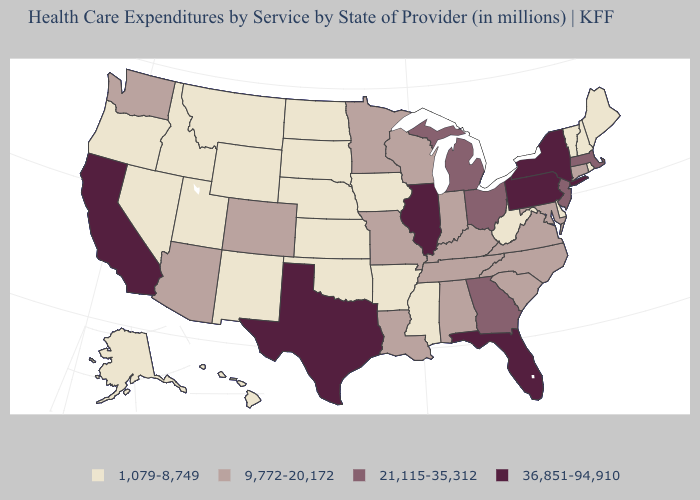What is the value of Vermont?
Answer briefly. 1,079-8,749. What is the highest value in the Northeast ?
Concise answer only. 36,851-94,910. What is the value of Ohio?
Keep it brief. 21,115-35,312. Among the states that border New Hampshire , which have the lowest value?
Write a very short answer. Maine, Vermont. Name the states that have a value in the range 1,079-8,749?
Answer briefly. Alaska, Arkansas, Delaware, Hawaii, Idaho, Iowa, Kansas, Maine, Mississippi, Montana, Nebraska, Nevada, New Hampshire, New Mexico, North Dakota, Oklahoma, Oregon, Rhode Island, South Dakota, Utah, Vermont, West Virginia, Wyoming. Name the states that have a value in the range 21,115-35,312?
Give a very brief answer. Georgia, Massachusetts, Michigan, New Jersey, Ohio. Does the map have missing data?
Answer briefly. No. Name the states that have a value in the range 9,772-20,172?
Answer briefly. Alabama, Arizona, Colorado, Connecticut, Indiana, Kentucky, Louisiana, Maryland, Minnesota, Missouri, North Carolina, South Carolina, Tennessee, Virginia, Washington, Wisconsin. What is the lowest value in the South?
Concise answer only. 1,079-8,749. Does the first symbol in the legend represent the smallest category?
Be succinct. Yes. Does the map have missing data?
Quick response, please. No. Among the states that border Delaware , does Maryland have the lowest value?
Give a very brief answer. Yes. Among the states that border Missouri , does Illinois have the lowest value?
Be succinct. No. 